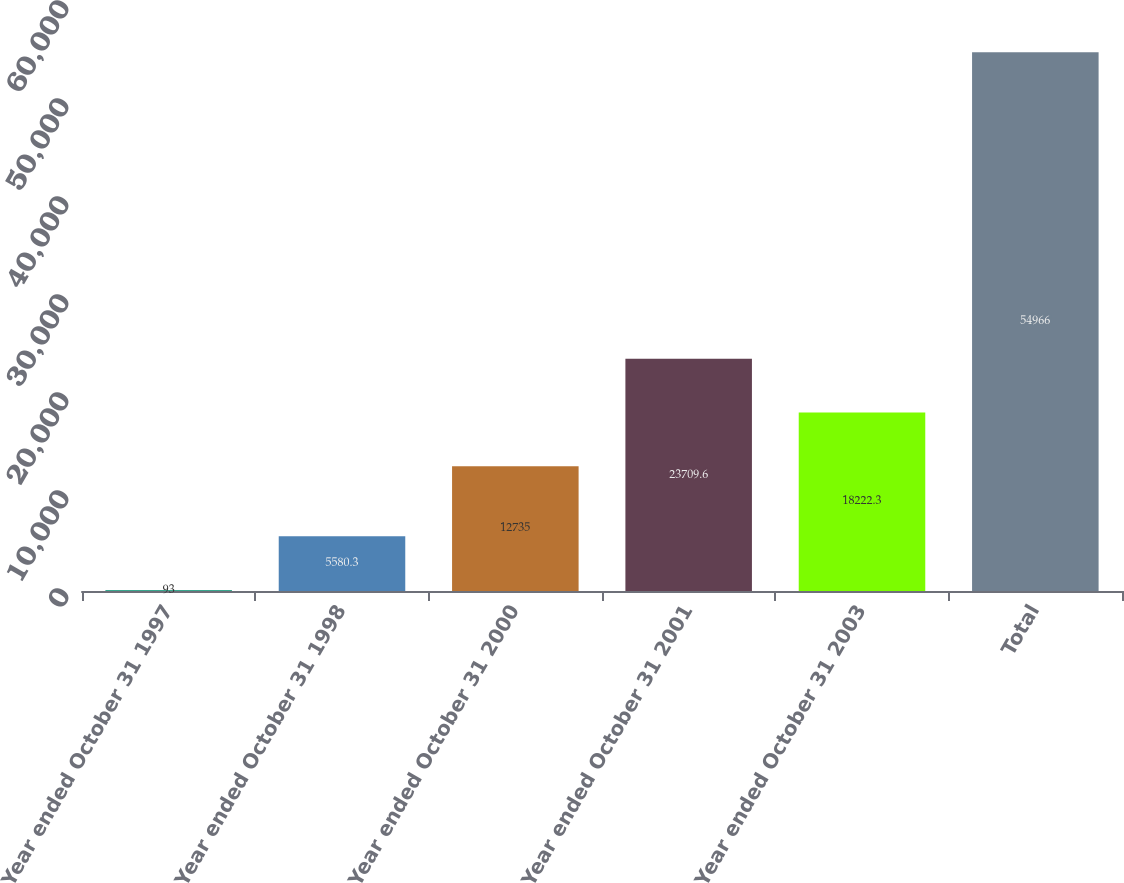Convert chart to OTSL. <chart><loc_0><loc_0><loc_500><loc_500><bar_chart><fcel>Year ended October 31 1997<fcel>Year ended October 31 1998<fcel>Year ended October 31 2000<fcel>Year ended October 31 2001<fcel>Year ended October 31 2003<fcel>Total<nl><fcel>93<fcel>5580.3<fcel>12735<fcel>23709.6<fcel>18222.3<fcel>54966<nl></chart> 